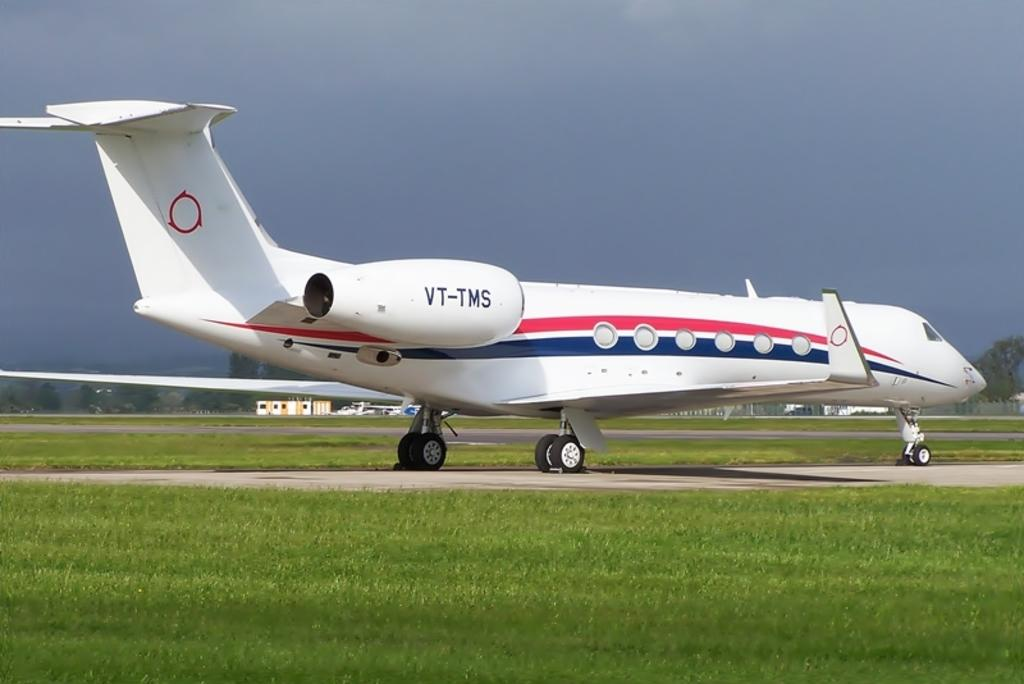<image>
Describe the image concisely. A red white and blue airplane with VT-TMS on it 